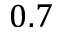Convert formula to latex. <formula><loc_0><loc_0><loc_500><loc_500>0 . 7</formula> 